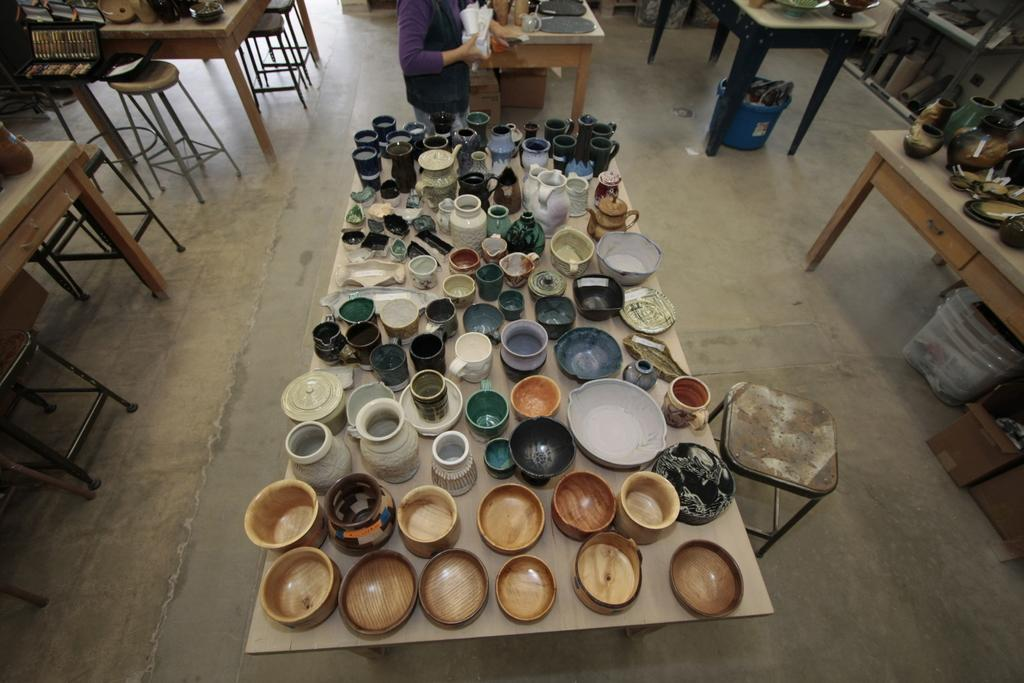What is the primary subject in the image? There is a person standing in the image. What is the person holding in the image? The person is holding objects. What types of containers are visible in the image? There are kettles, jars, bowls, and cups in the image. What types of furniture are visible in the image? There are tables and chairs in the image. What types of storage containers are visible in the image? There are boxes in the image. What part of the room is visible in the image? The floor is visible in the image. Are there any objects on the floor in the image? Yes, there are objects on the floor in the image. How many times does the person kiss the destruction in the image? There is no destruction or kissing present in the image. 